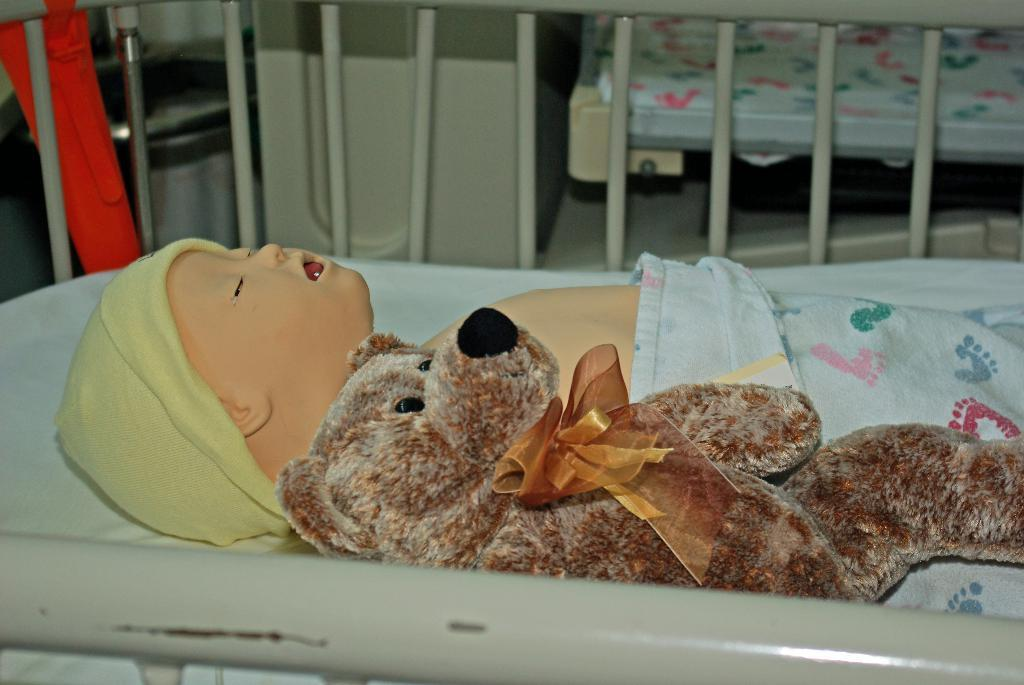What is the main object in the image? There is a cradle in the image. What can be found inside the cradle? There is a baby toy inside the cradle. What other object is near the baby toy? There is a teddy bear beside the baby toy. What can be seen in the background of the image? There is a bed and an iron board in the background. What type of scent is coming from the hat in the image? There is no hat present in the image, so it is not possible to determine the scent. 